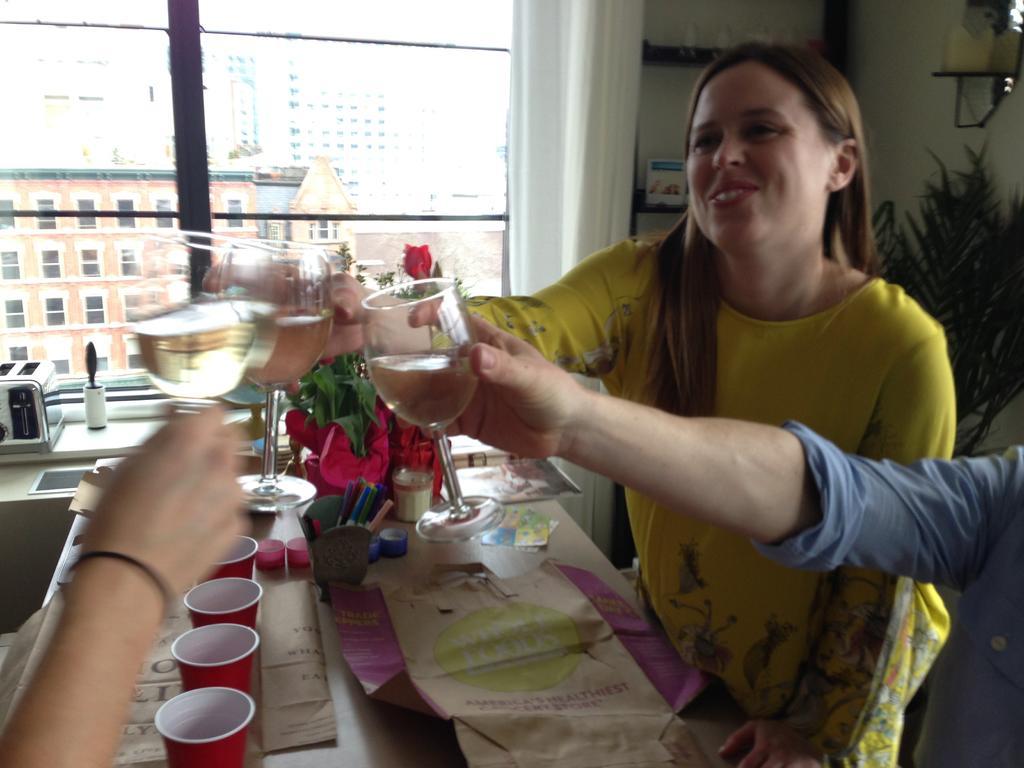Describe this image in one or two sentences. In this picture there is a woman wearing a yellow dress, holding a glass. In the left side and right side there are human hands holding a glasses. In the center there is a table, on the table there are glasses, papers and a plant. In the background there is a window, through a window there is a building. 